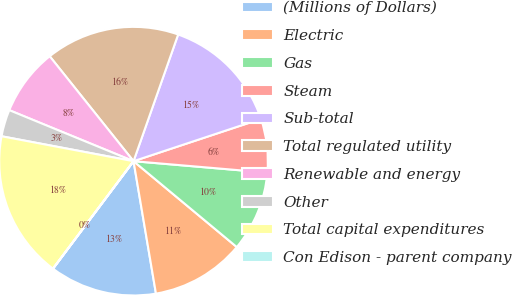Convert chart. <chart><loc_0><loc_0><loc_500><loc_500><pie_chart><fcel>(Millions of Dollars)<fcel>Electric<fcel>Gas<fcel>Steam<fcel>Sub-total<fcel>Total regulated utility<fcel>Renewable and energy<fcel>Other<fcel>Total capital expenditures<fcel>Con Edison - parent company<nl><fcel>12.9%<fcel>11.29%<fcel>9.68%<fcel>6.46%<fcel>14.51%<fcel>16.12%<fcel>8.07%<fcel>3.23%<fcel>17.73%<fcel>0.01%<nl></chart> 